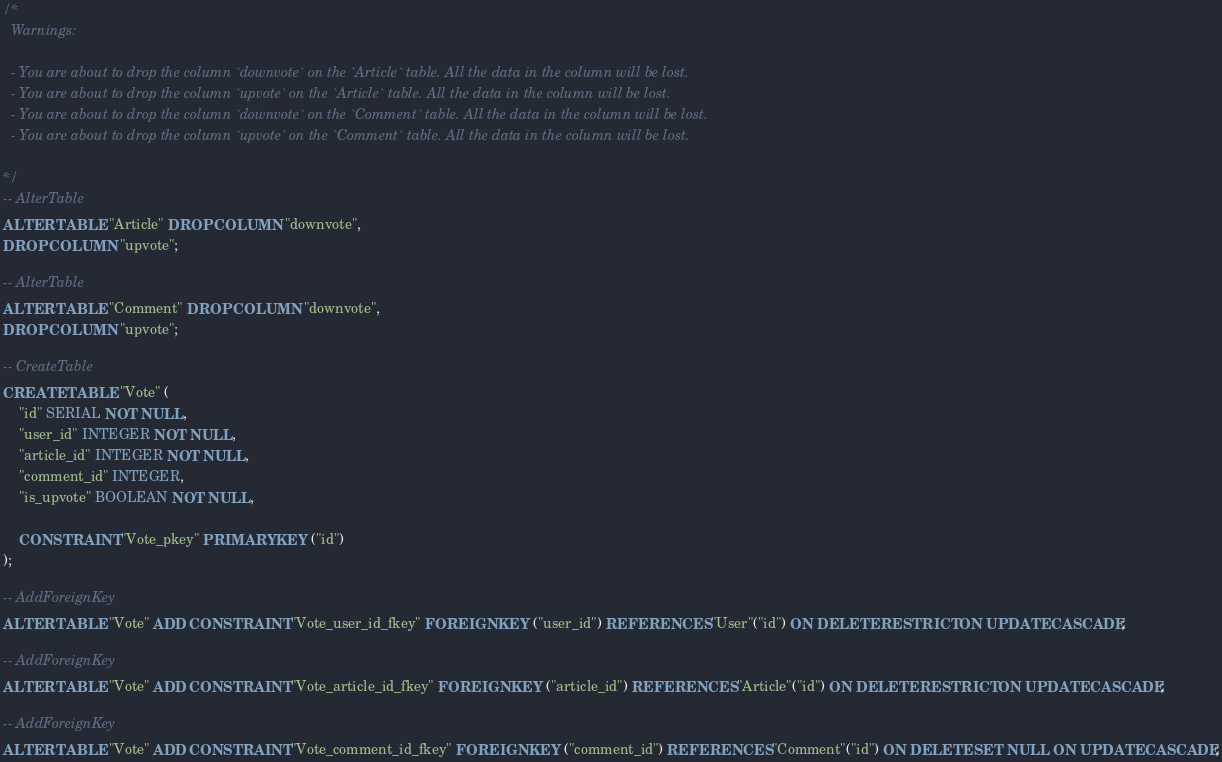Convert code to text. <code><loc_0><loc_0><loc_500><loc_500><_SQL_>/*
  Warnings:

  - You are about to drop the column `downvote` on the `Article` table. All the data in the column will be lost.
  - You are about to drop the column `upvote` on the `Article` table. All the data in the column will be lost.
  - You are about to drop the column `downvote` on the `Comment` table. All the data in the column will be lost.
  - You are about to drop the column `upvote` on the `Comment` table. All the data in the column will be lost.

*/
-- AlterTable
ALTER TABLE "Article" DROP COLUMN "downvote",
DROP COLUMN "upvote";

-- AlterTable
ALTER TABLE "Comment" DROP COLUMN "downvote",
DROP COLUMN "upvote";

-- CreateTable
CREATE TABLE "Vote" (
    "id" SERIAL NOT NULL,
    "user_id" INTEGER NOT NULL,
    "article_id" INTEGER NOT NULL,
    "comment_id" INTEGER,
    "is_upvote" BOOLEAN NOT NULL,

    CONSTRAINT "Vote_pkey" PRIMARY KEY ("id")
);

-- AddForeignKey
ALTER TABLE "Vote" ADD CONSTRAINT "Vote_user_id_fkey" FOREIGN KEY ("user_id") REFERENCES "User"("id") ON DELETE RESTRICT ON UPDATE CASCADE;

-- AddForeignKey
ALTER TABLE "Vote" ADD CONSTRAINT "Vote_article_id_fkey" FOREIGN KEY ("article_id") REFERENCES "Article"("id") ON DELETE RESTRICT ON UPDATE CASCADE;

-- AddForeignKey
ALTER TABLE "Vote" ADD CONSTRAINT "Vote_comment_id_fkey" FOREIGN KEY ("comment_id") REFERENCES "Comment"("id") ON DELETE SET NULL ON UPDATE CASCADE;
</code> 